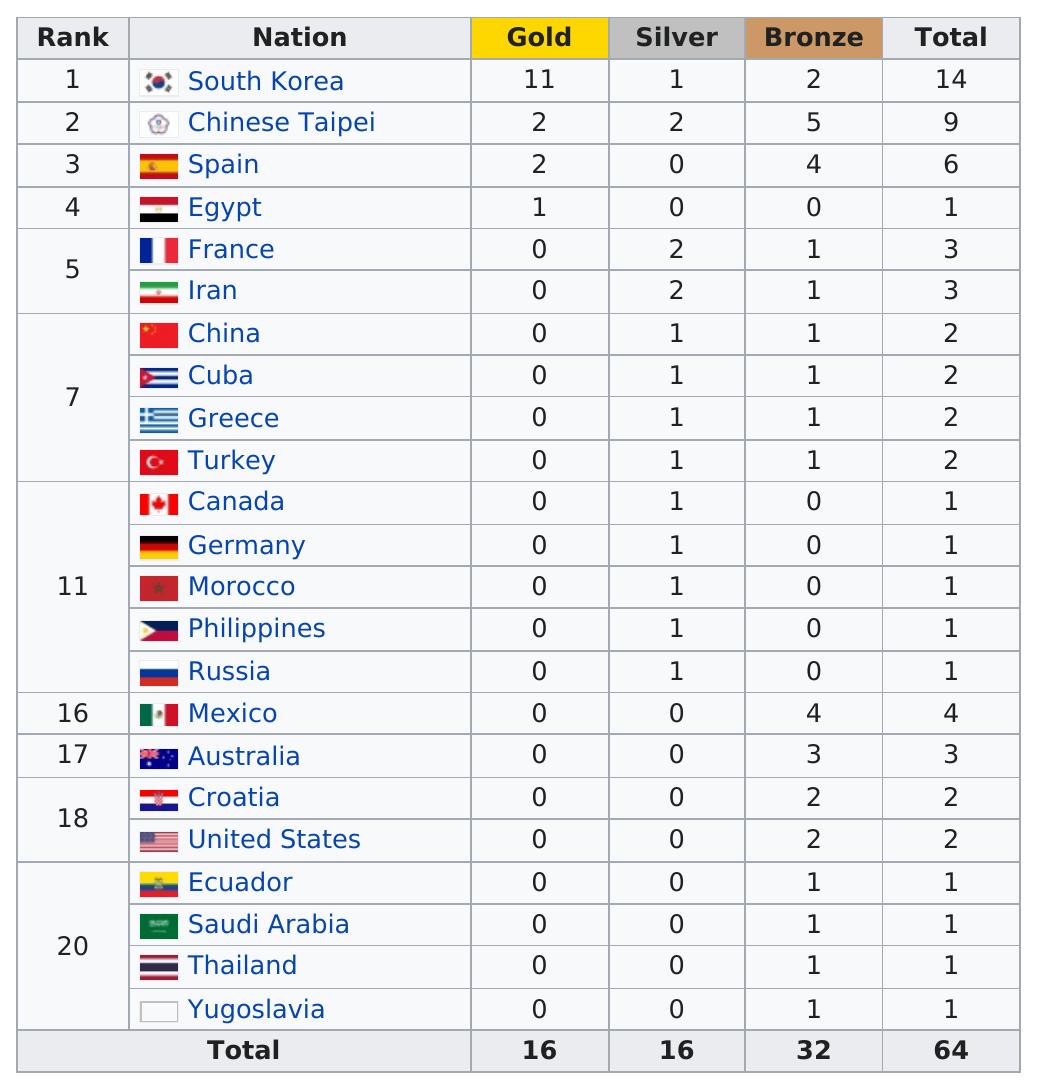Draw attention to some important aspects in this diagram. The total number of gold awards won between Spain and Egypt was three. France was the only nation ranked fifth at the 1997 World Taekwondo Championships, except for Iran. Mexico did not receive more bronze medals than Chinese Taipei. Out of the countries that have won at most 5 medals, 3 of them are countries. The total number of medals for Spain is 6. 